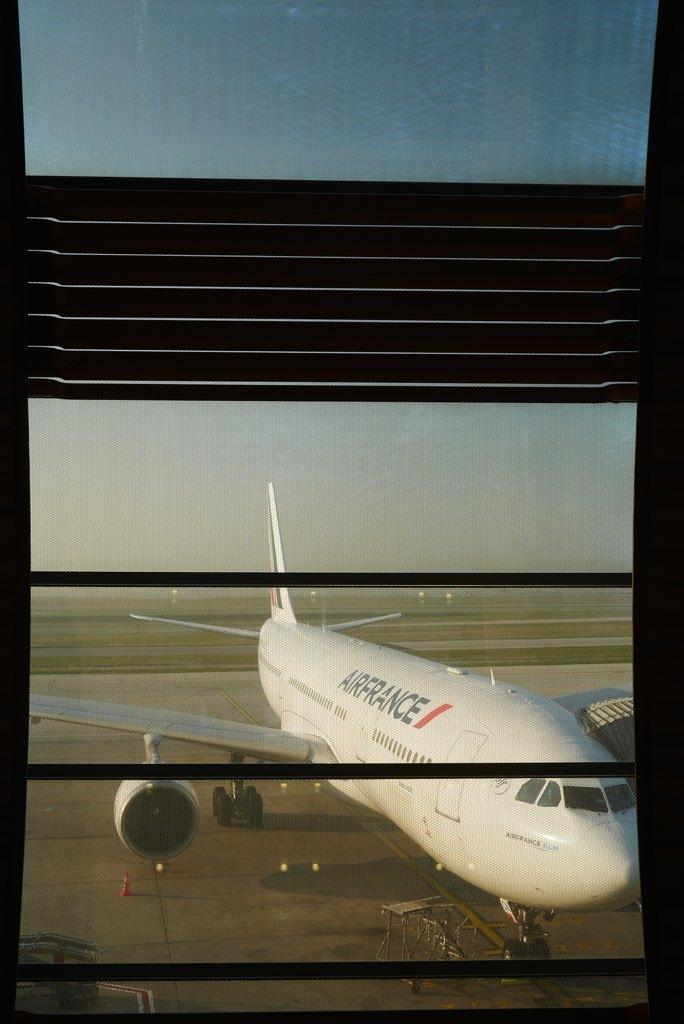<image>
Give a short and clear explanation of the subsequent image. A large Airfrance plane sits on the runway. 